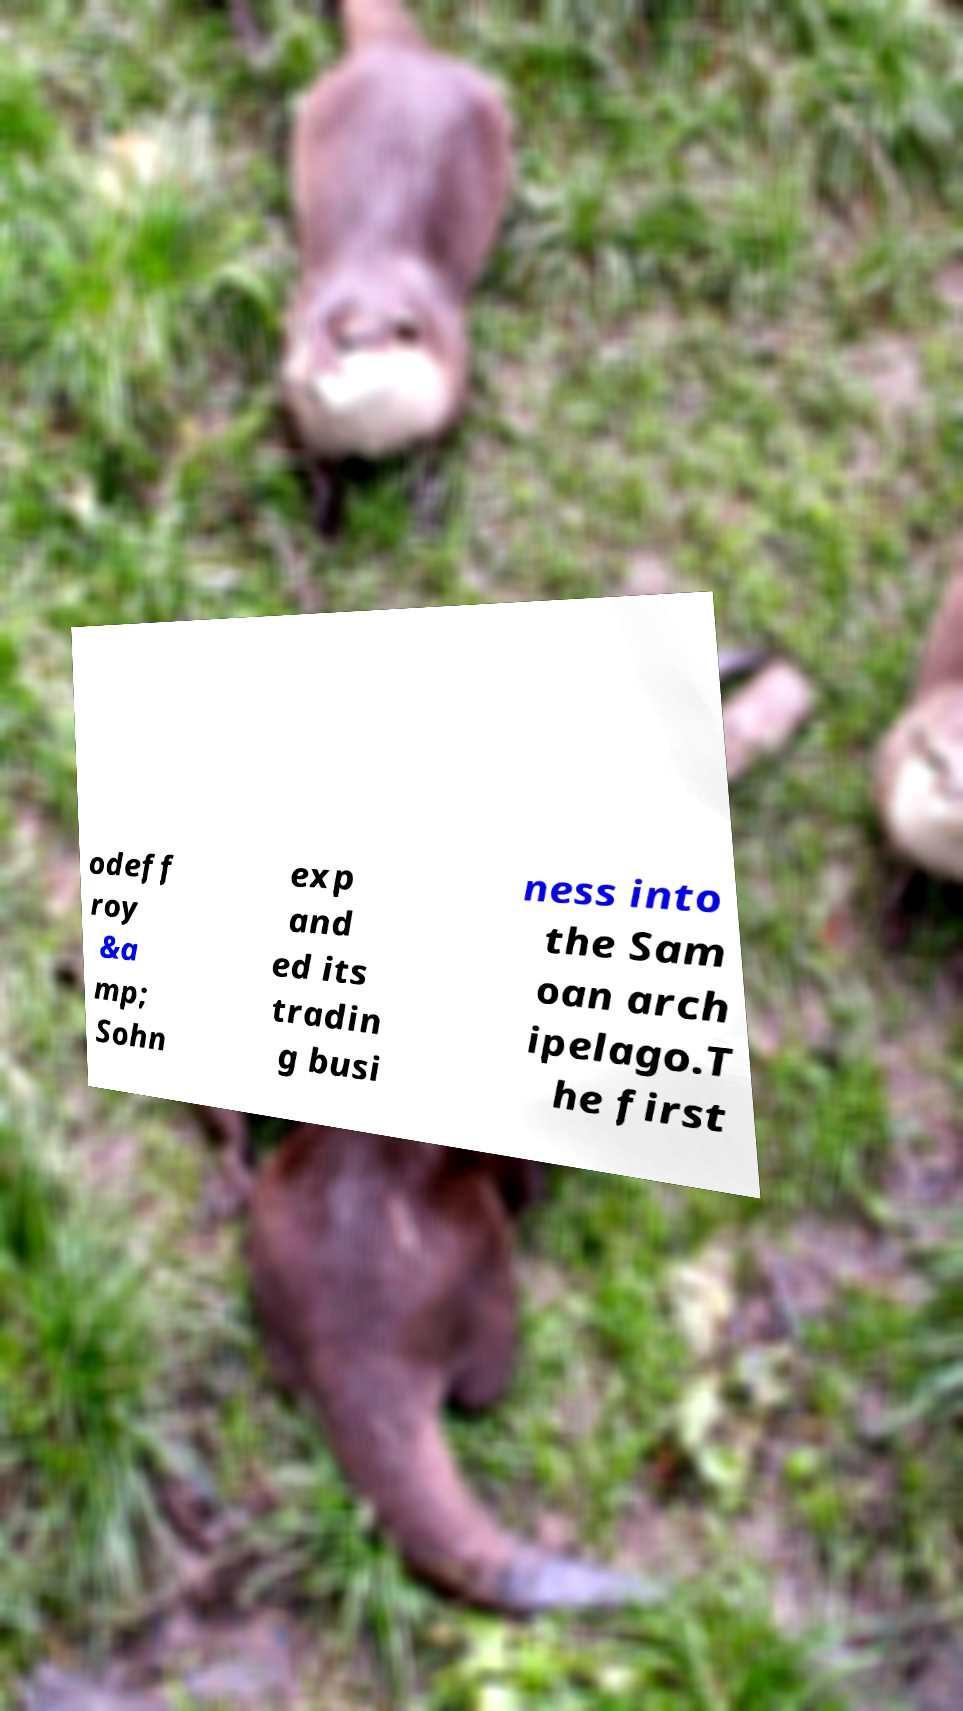What messages or text are displayed in this image? I need them in a readable, typed format. odeff roy &a mp; Sohn exp and ed its tradin g busi ness into the Sam oan arch ipelago.T he first 